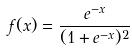<formula> <loc_0><loc_0><loc_500><loc_500>f ( x ) = \frac { e ^ { - x } } { ( 1 + e ^ { - x } ) ^ { 2 } }</formula> 